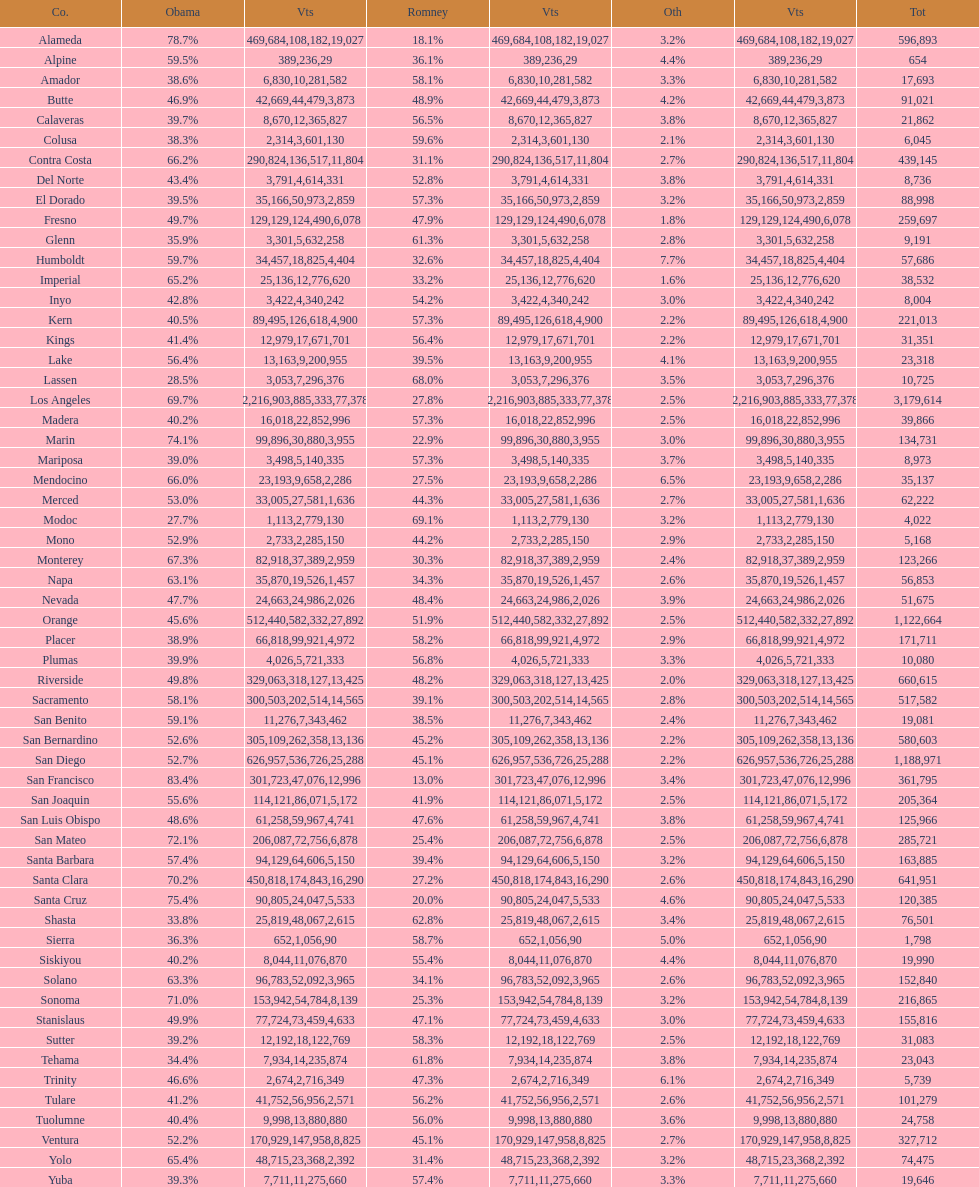What county is just before del norte on the list? Contra Costa. 